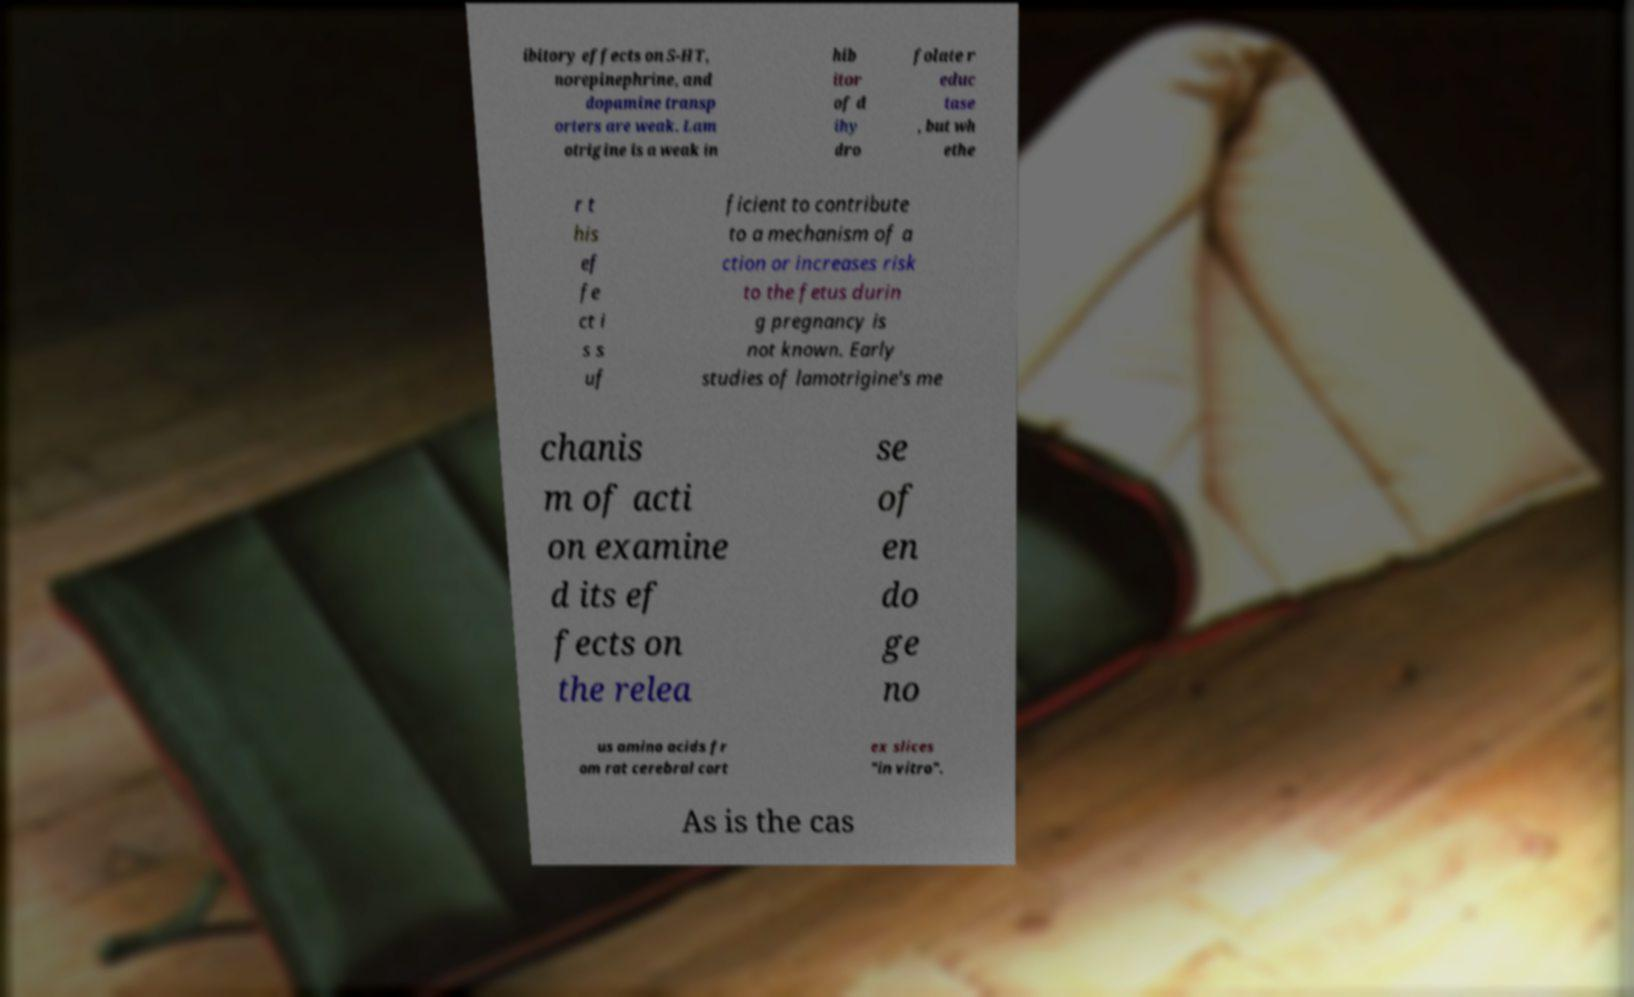Can you accurately transcribe the text from the provided image for me? ibitory effects on 5-HT, norepinephrine, and dopamine transp orters are weak. Lam otrigine is a weak in hib itor of d ihy dro folate r educ tase , but wh ethe r t his ef fe ct i s s uf ficient to contribute to a mechanism of a ction or increases risk to the fetus durin g pregnancy is not known. Early studies of lamotrigine's me chanis m of acti on examine d its ef fects on the relea se of en do ge no us amino acids fr om rat cerebral cort ex slices "in vitro". As is the cas 